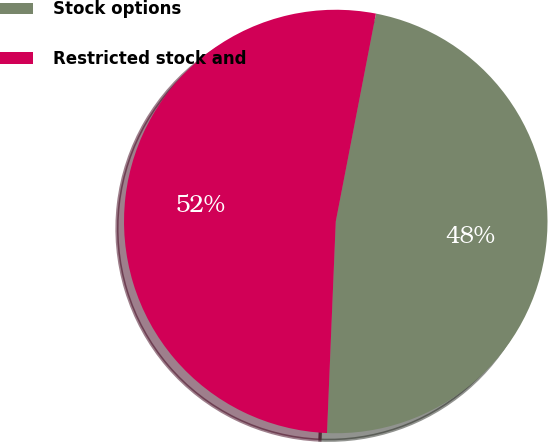Convert chart. <chart><loc_0><loc_0><loc_500><loc_500><pie_chart><fcel>Stock options<fcel>Restricted stock and<nl><fcel>47.62%<fcel>52.38%<nl></chart> 